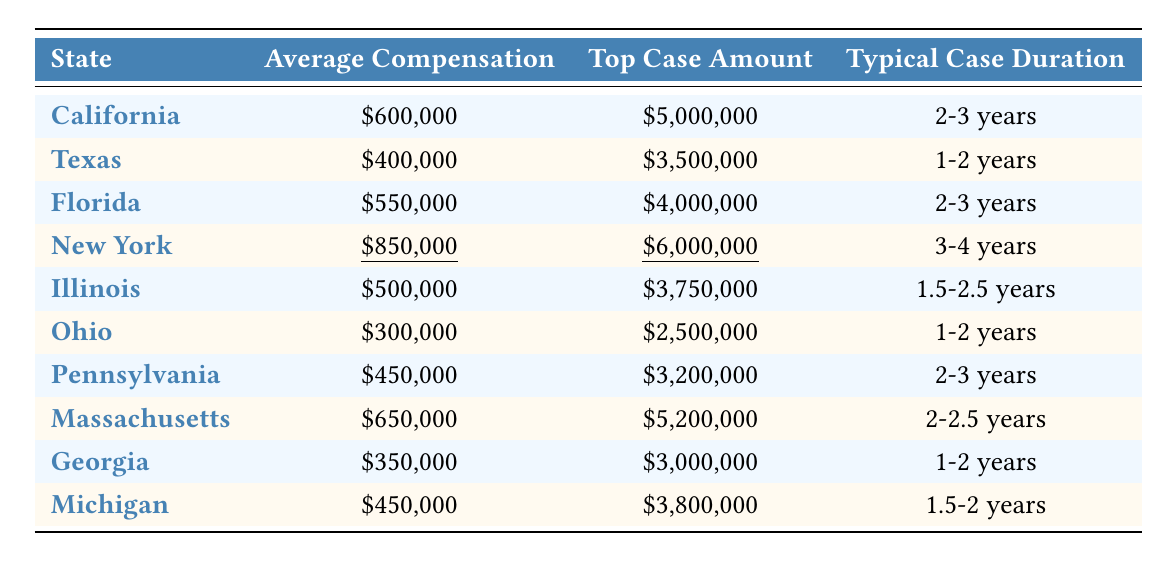What is the average compensation amount in New York? In the table, for New York, the row specifies that the average compensation is highlighted and shown as $850,000.
Answer: $850,000 Which state has the highest average compensation? By reviewing the average compensation values listed, New York has the highest figure at $850,000 compared to all other states.
Answer: New York How much longer does a typical case take in New York compared to Texas? The typical case duration in New York is 3-4 years, while in Texas, it is 1-2 years. This means that New York's case duration is approximately 1 to 2 years longer than Texas when considering the overlap.
Answer: 1 to 2 years longer Is the average compensation in Illinois higher than in Pennsylvania? The average compensation in Illinois is $500,000, while in Pennsylvania, it is $450,000, thus Illinois has a higher average.
Answer: Yes What is the median average compensation amount from the states listed? First, the averages are $600,000, $400,000, $550,000, $850,000, $500,000, $300,000, $450,000, $650,000, $350,000, $450,000. Sorting these gives: $300,000, $350,000, $400,000, $450,000, $450,000, $500,000, $550,000, $600,000, $650,000, $850,000. With ten data points, the median is the average of the 5th and 6th values: (450,000 + 500,000) / 2 = $475,000.
Answer: $475,000 What is the total average compensation amount for Florida, Massachusetts, and California combined? Adding the average compensations for these states: Florida ($550,000) + Massachusetts ($650,000) + California ($600,000) gives $550,000 + $650,000 + $600,000 = $1,800,000.
Answer: $1,800,000 Which state has the lowest average compensation amount? The table shows Ohio with the lowest average compensation at $300,000 compared to all other states listed.
Answer: Ohio What is the range of typical case durations across all states in the table? The shortest duration is 1 year (Ohio, Texas, Georgia), and the longest is 4 years (New York). The range is from 1 to 4 years.
Answer: 1 to 4 years Do any states have the same average compensation? Looking through the table, the average compensation for both Michigan and Pennsylvania is $450,000, indicating they share this amount.
Answer: Yes How much more can one expect as a top case amount in Florida compared to Ohio? The top case amount in Florida is $4,000,000 and in Ohio it's $2,500,000. The difference is $4,000,000 - $2,500,000 = $1,500,000.
Answer: $1,500,000 In which state does the typical case duration exceed 3 years? Analyzing the typical case duration for each state, New York is the only state with a duration of 3-4 years, exceeding 3 years.
Answer: New York 